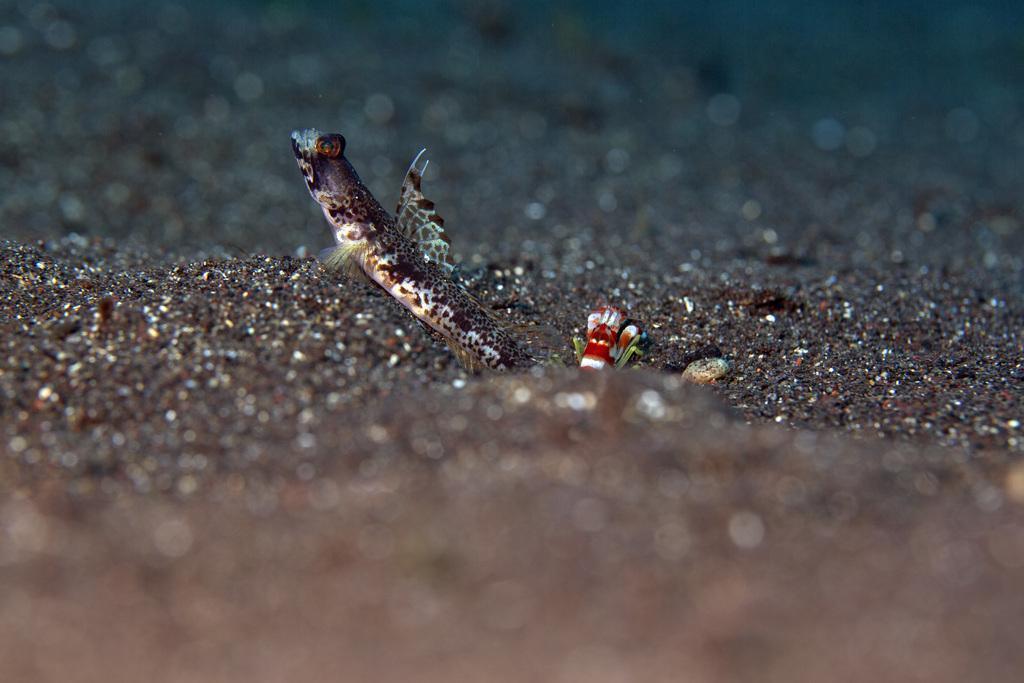How would you summarize this image in a sentence or two? In this image I can see two different types of fish and the black soil. I can also see this image is little bit blurry. 